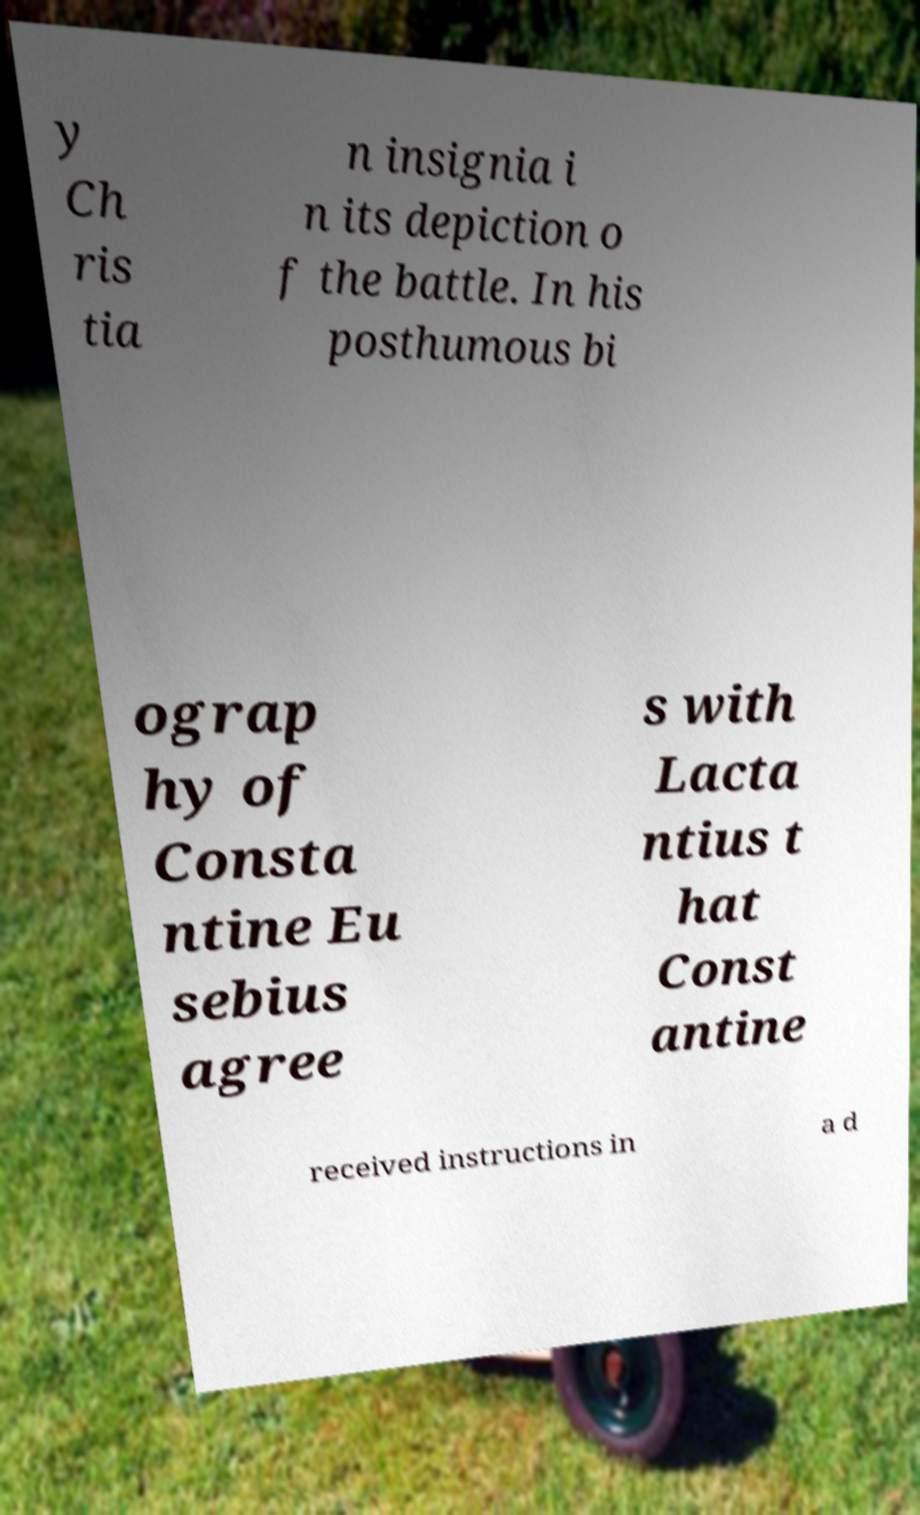Can you read and provide the text displayed in the image?This photo seems to have some interesting text. Can you extract and type it out for me? y Ch ris tia n insignia i n its depiction o f the battle. In his posthumous bi ograp hy of Consta ntine Eu sebius agree s with Lacta ntius t hat Const antine received instructions in a d 